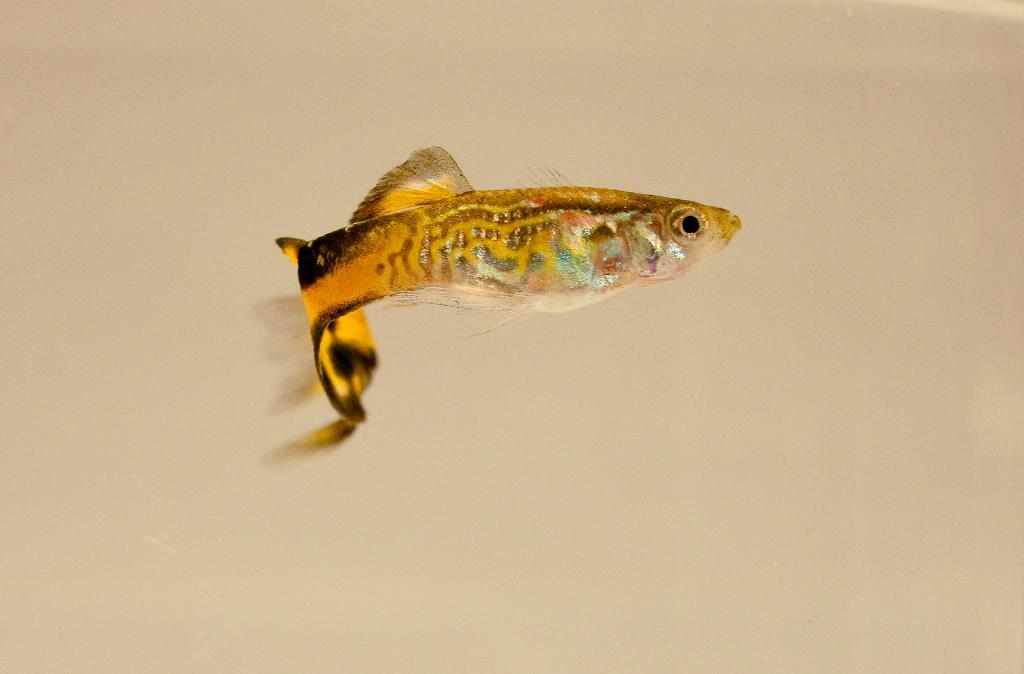What type of animal is in the image? There is a fish in the image. Can you describe the colors of the fish? The fish has yellow, black, gold, cream, and blue colors. What is the color of the surface the fish is on? The fish is on a cream-colored surface. What type of sign is the fish holding in the image? There is no sign present in the image, and the fish is not holding anything. 